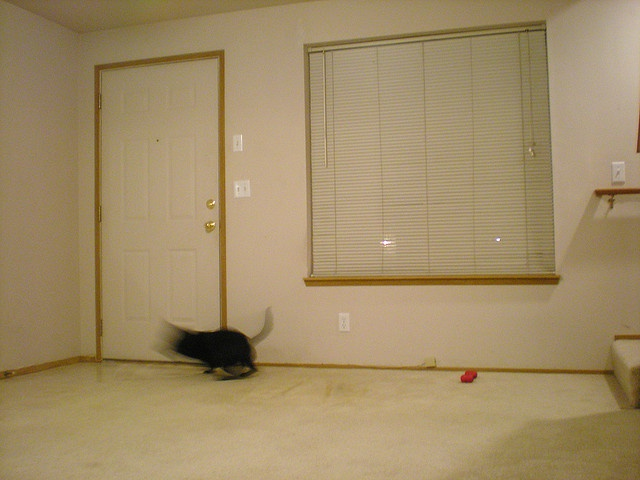Describe the objects in this image and their specific colors. I can see a cat in olive and black tones in this image. 